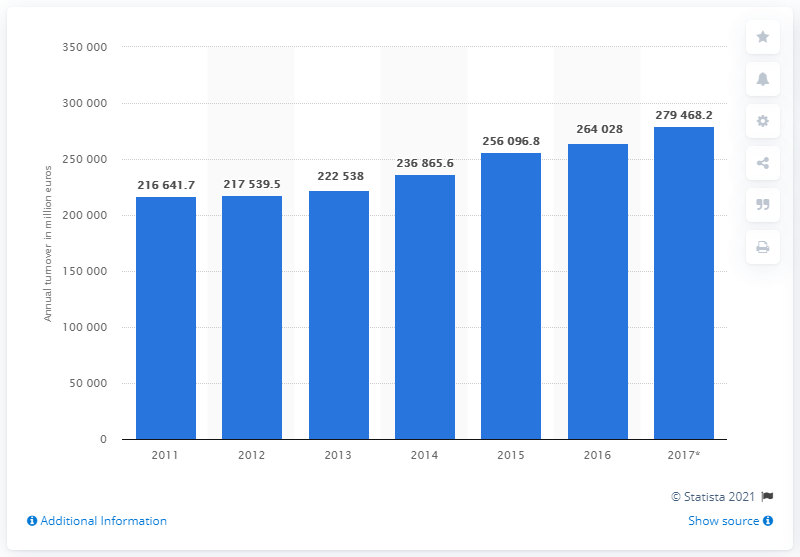List a handful of essential elements in this visual. In 2017, the turnover of the restaurants and mobile food service activities industry in the European Union was 279,468.2. 